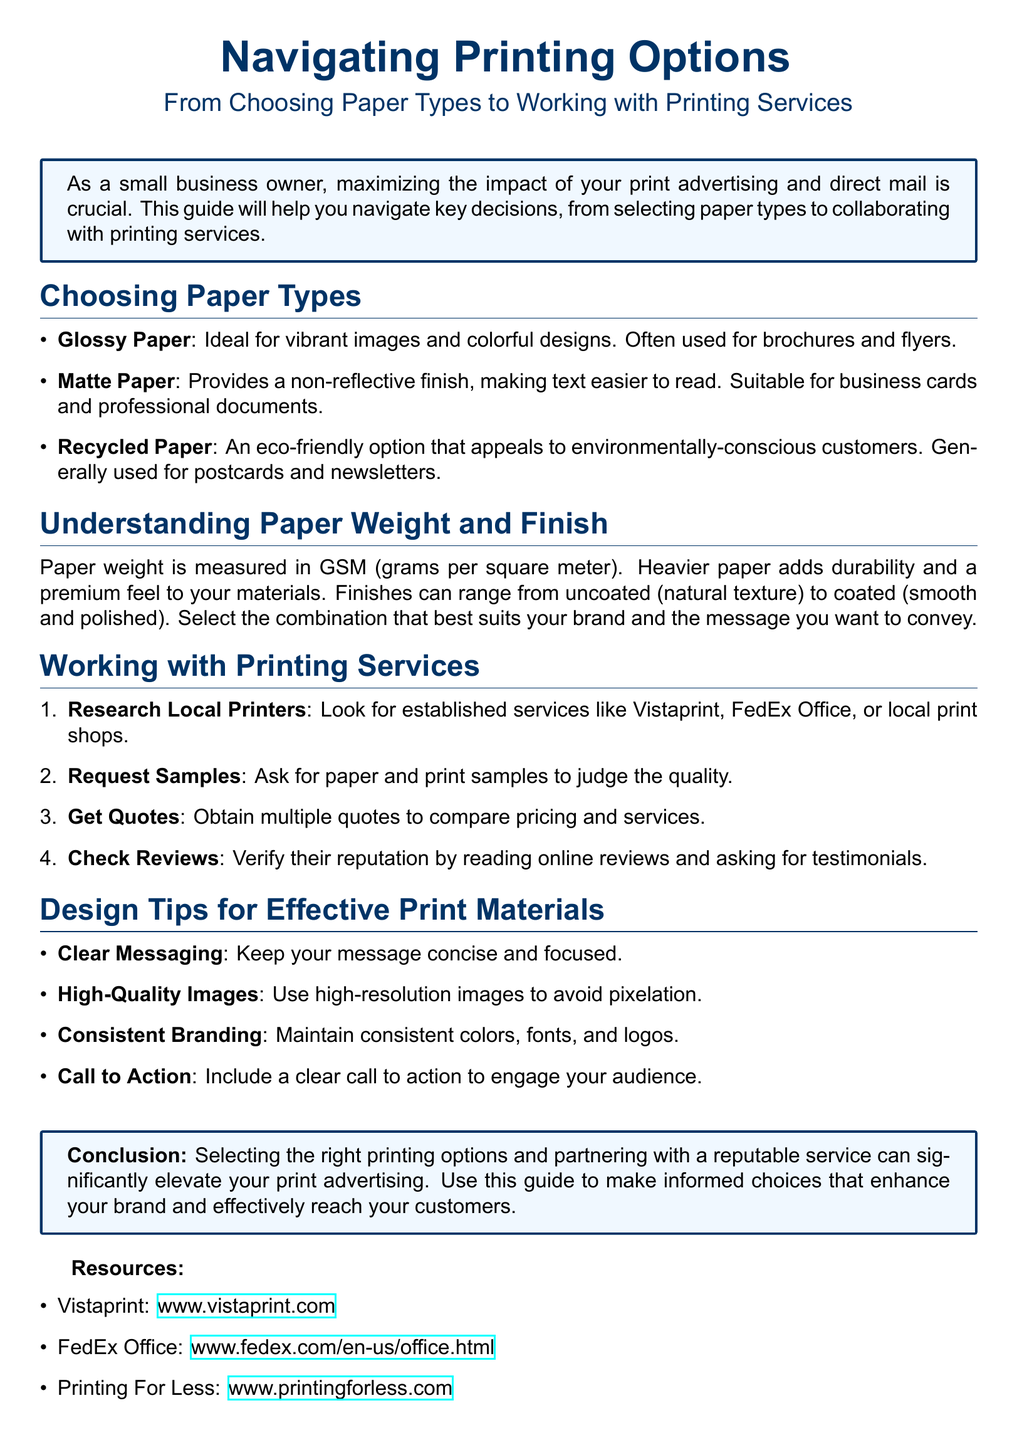What is the purpose of this user guide? The user guide aims to help small business owners navigate key decisions in printing, from selecting paper types to collaborating with printing services.
Answer: To help small business owners navigate printing options What are the three types of paper mentioned? The document lists Glossy Paper, Matte Paper, and Recycled Paper as types of paper.
Answer: Glossy Paper, Matte Paper, Recycled Paper What does GSM stand for in relation to paper weight? The document mentions that paper weight is measured in GSM, which stands for grams per square meter.
Answer: Grams per square meter Which printing service is listed first in the resources? The first printing service mentioned in the resources section is Vistaprint.
Answer: Vistaprint How many tips are provided for effective print materials? The guide presents four tips for effective print materials under the Design Tips section.
Answer: Four tips What is one benefit of using Recycled Paper? The document states that Recycled Paper is an eco-friendly option appealing to environmentally-conscious customers.
Answer: Eco-friendly What should you do before selecting a printing service? The document suggests researching local printers before selecting a printing service.
Answer: Research local printers What is emphasized as important for clarity in print materials? The document highlights that clear messaging is important for clarity in print materials.
Answer: Clear messaging 